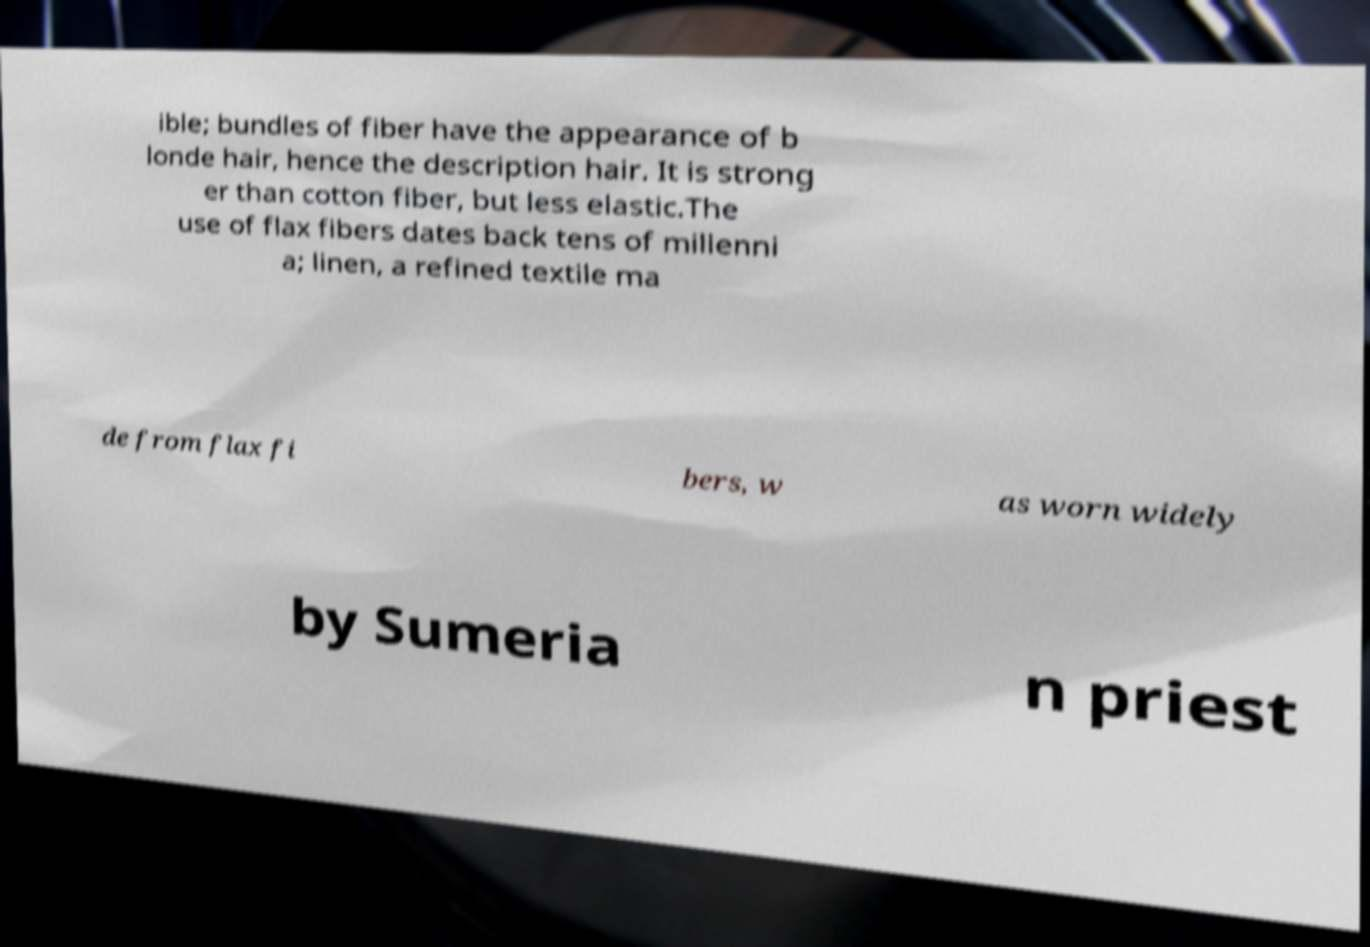Can you accurately transcribe the text from the provided image for me? ible; bundles of fiber have the appearance of b londe hair, hence the description hair. It is strong er than cotton fiber, but less elastic.The use of flax fibers dates back tens of millenni a; linen, a refined textile ma de from flax fi bers, w as worn widely by Sumeria n priest 